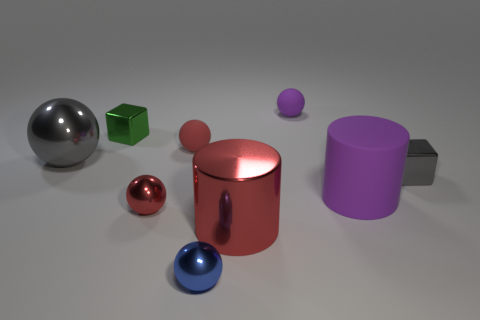Subtract all gray spheres. How many spheres are left? 4 Subtract all small red metallic spheres. How many spheres are left? 4 Subtract all purple spheres. Subtract all cyan cylinders. How many spheres are left? 4 Add 1 tiny red things. How many objects exist? 10 Subtract all spheres. How many objects are left? 4 Add 3 blue spheres. How many blue spheres are left? 4 Add 8 large green spheres. How many large green spheres exist? 8 Subtract 2 red balls. How many objects are left? 7 Subtract all tiny red shiny things. Subtract all purple matte cylinders. How many objects are left? 7 